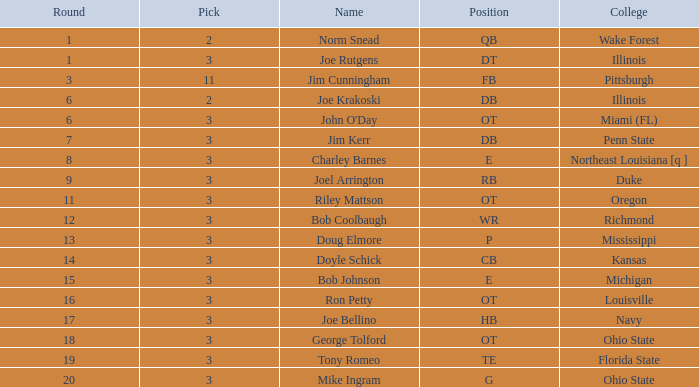How many rounds have john o'day as the name, and a pick less than 3? None. 